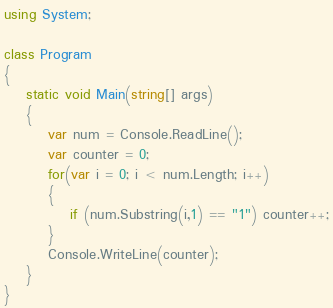<code> <loc_0><loc_0><loc_500><loc_500><_C#_>using System;

class Program
{
    static void Main(string[] args)
    {
        var num = Console.ReadLine();
        var counter = 0;
        for(var i = 0; i < num.Length; i++)
        {
            if (num.Substring(i,1) == "1") counter++;
        }
        Console.WriteLine(counter);
    }
}

</code> 